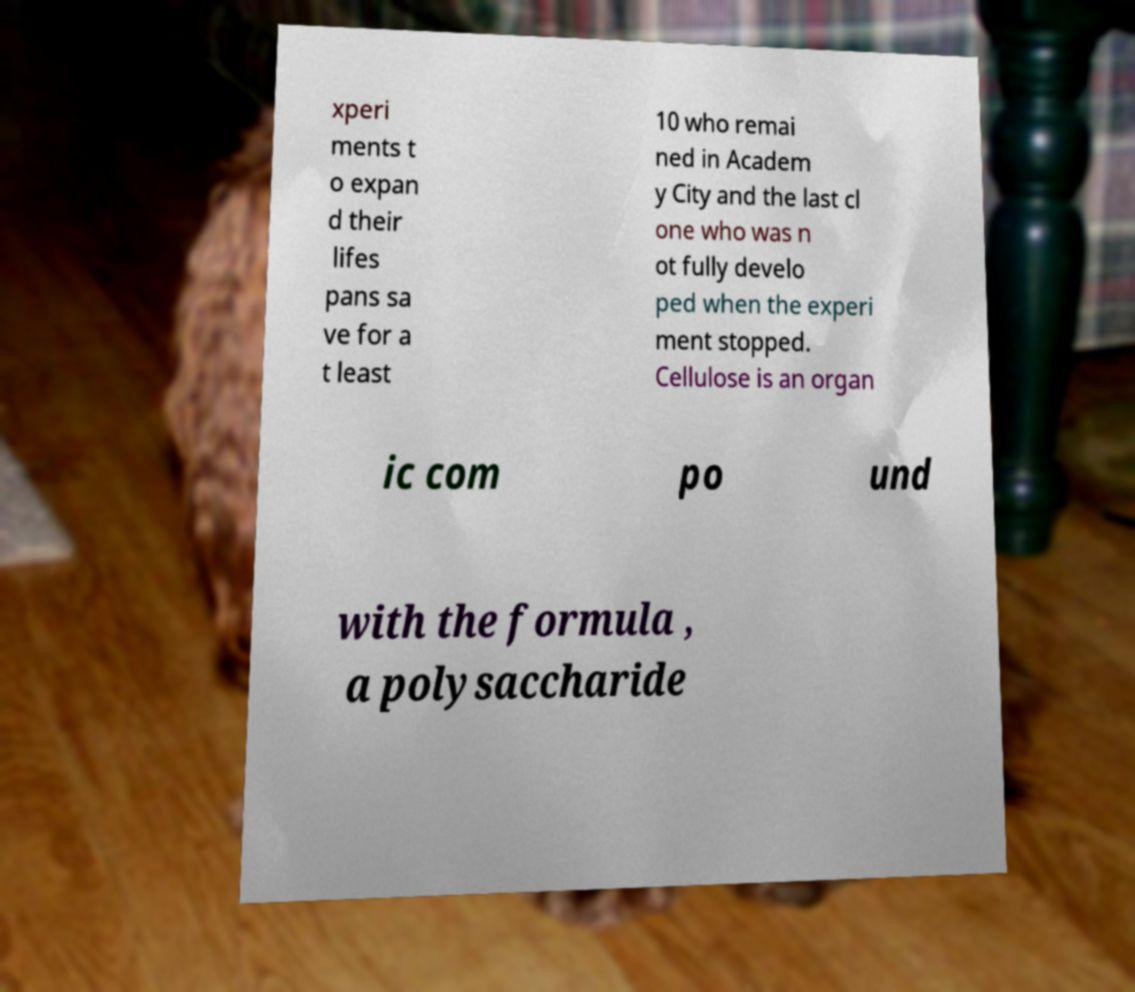Please read and relay the text visible in this image. What does it say? xperi ments t o expan d their lifes pans sa ve for a t least 10 who remai ned in Academ y City and the last cl one who was n ot fully develo ped when the experi ment stopped. Cellulose is an organ ic com po und with the formula , a polysaccharide 